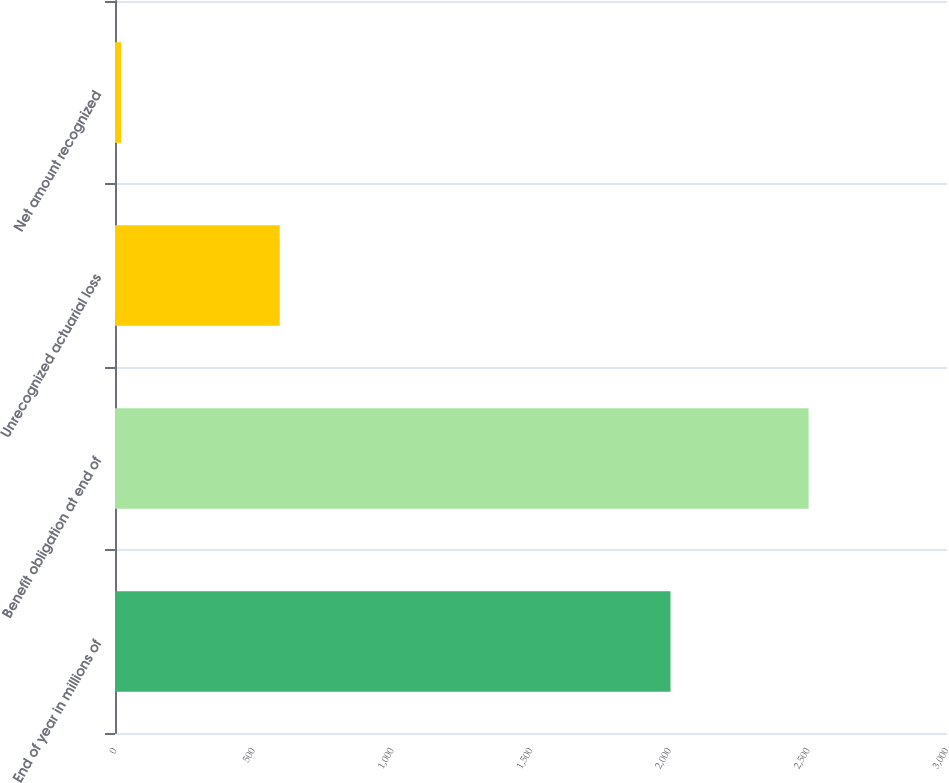Convert chart. <chart><loc_0><loc_0><loc_500><loc_500><bar_chart><fcel>End of year in millions of<fcel>Benefit obligation at end of<fcel>Unrecognized actuarial loss<fcel>Net amount recognized<nl><fcel>2003<fcel>2501<fcel>594<fcel>22<nl></chart> 